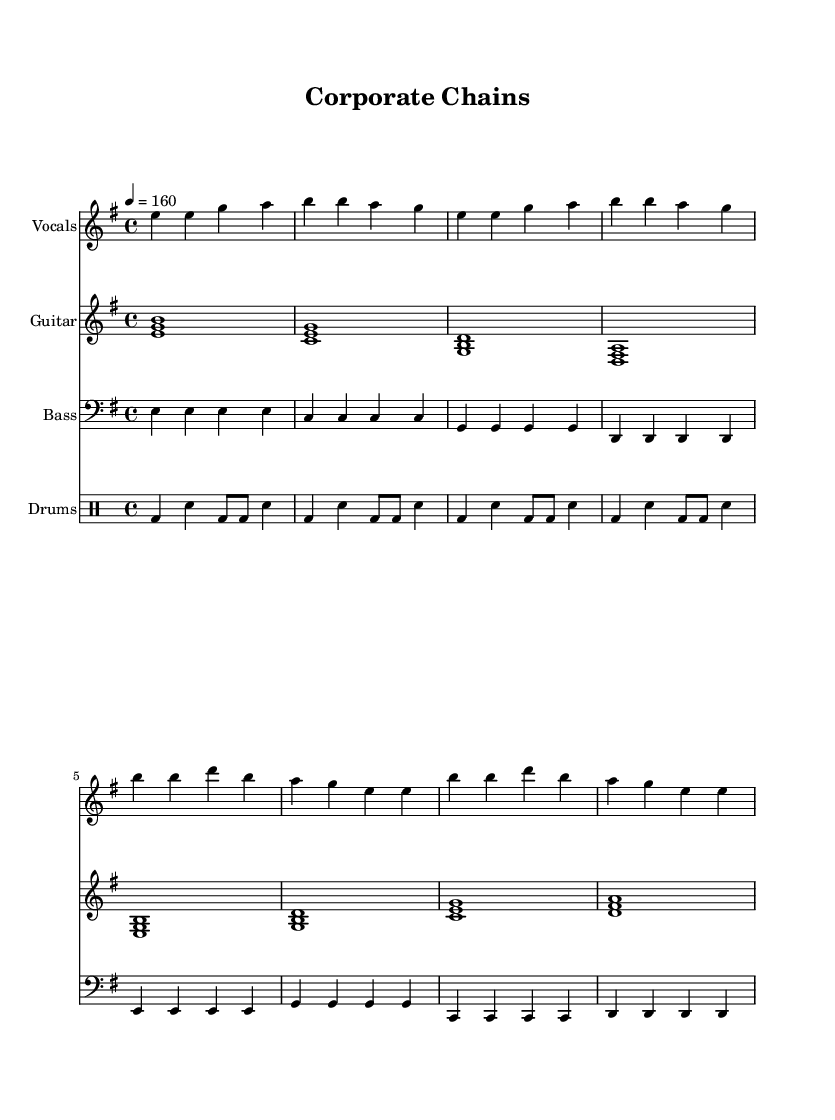What is the key signature of this music? The key signature is E minor, which has one sharp (F sharp). This can be identified by locating the key signature at the beginning of the staff, indicated by the sharp symbol before the first note.
Answer: E minor What is the time signature of this piece? The time signature is 4/4, which is indicated at the beginning of the staff. This means there are four beats in each measure, with the quarter note taking one beat.
Answer: 4/4 What is the tempo marking of the music? The tempo marking is 160 beats per minute (BPM), specified in numerical form below the tempo indication. This indicates how fast the piece should be played.
Answer: 160 How many measures are in the verse section? The verse section contains 4 measures, as seen by counting the number of vertical lines (bar lines) separating the music, ending the verse at the fourth bar.
Answer: 4 What are the primary themes expressed in the lyrics? The lyrics focus on corporate chains stifling local voices and the call to reclaim autonomy. This can be inferred from analyzing the text provided along with the vocal part, highlighting the anti-establishment sentiment typical of punk rock.
Answer: Anti-establishment What instrument plays the rhythm guitar part? The rhythm guitar part is represented by the staff labeled "Guitar." This is clearly indicated at the beginning of the corresponding staff.
Answer: Guitar Which part contains the percussion? The percussion is found in the staff labeled "Drums." The drum notation is distinctly in a different staff type designed for drum notation.
Answer: Drums 